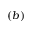<formula> <loc_0><loc_0><loc_500><loc_500>( b )</formula> 